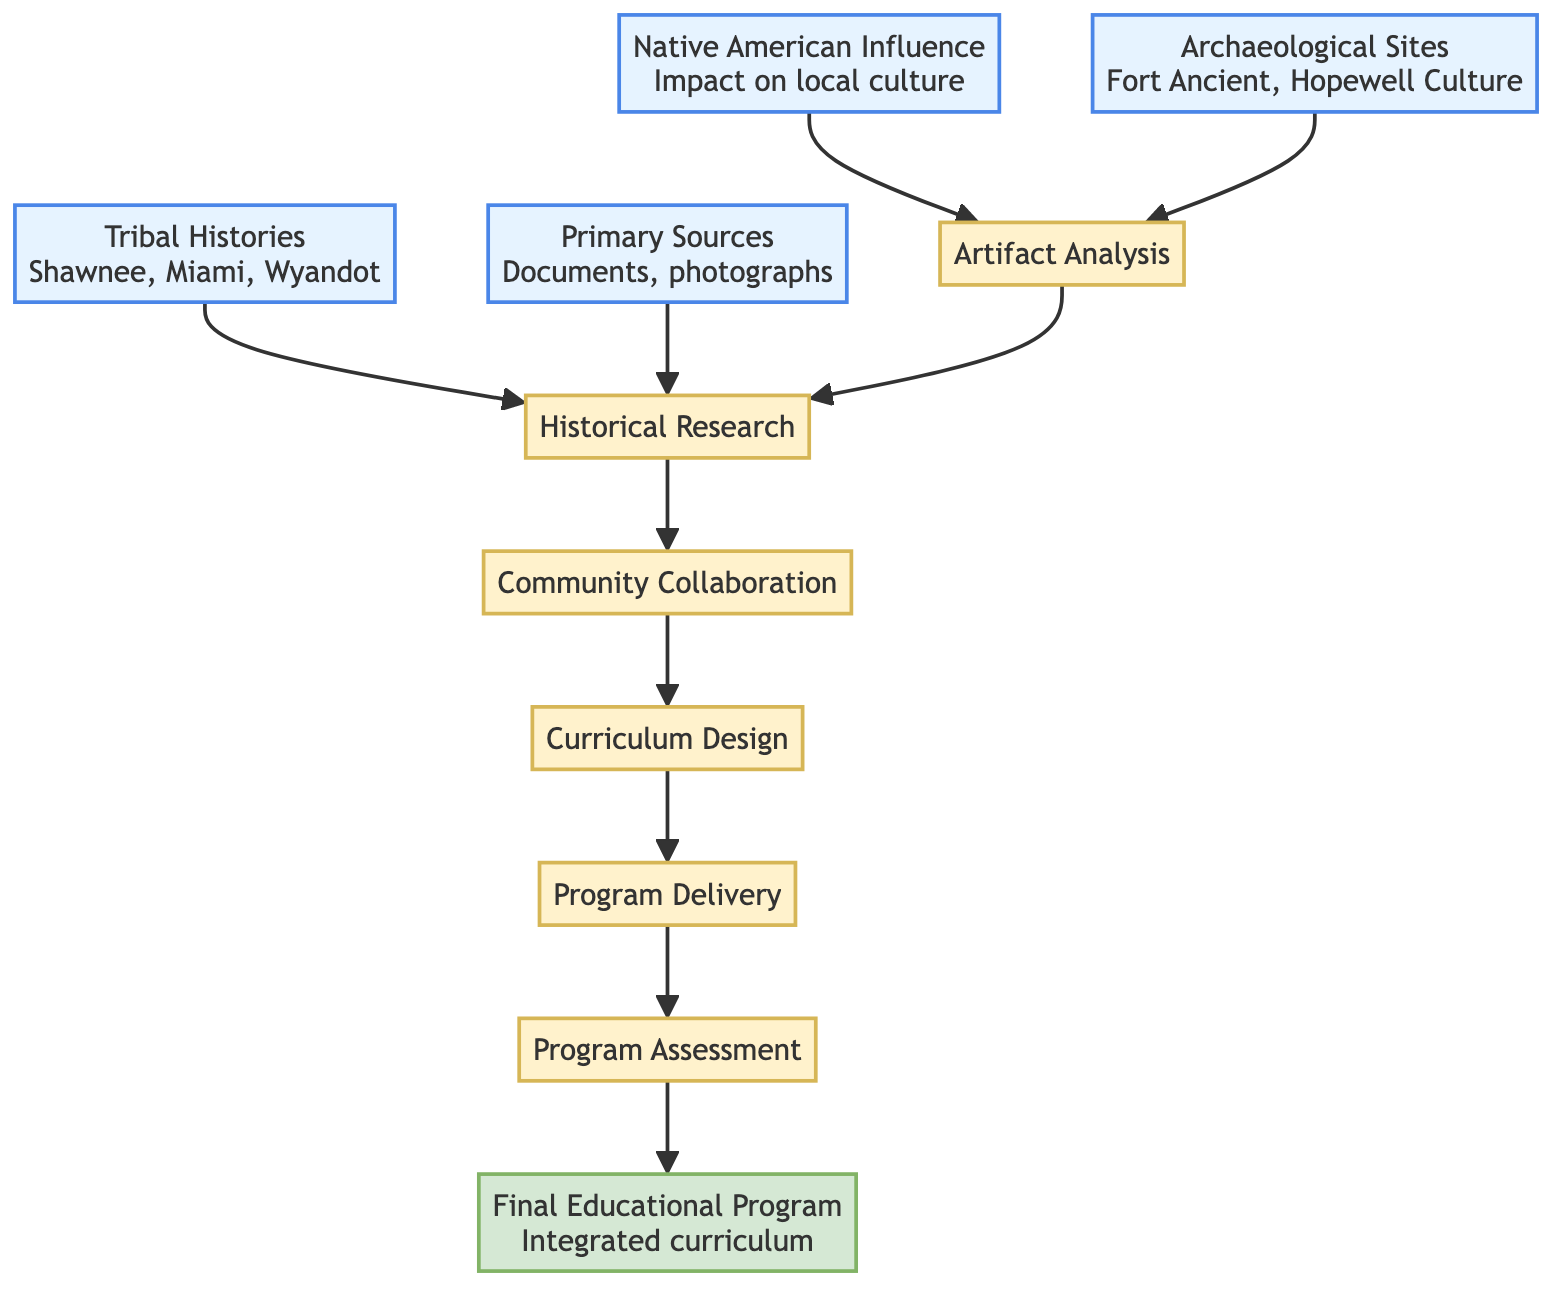What is the final output of the diagram? The final output of the diagram is found at the top of the flowchart, labeled as "Final Educational Program," which describes a completed curriculum that integrates all elements of Ohio's Native American cultural heritage.
Answer: Final Educational Program How many data nodes are present in the diagram? By examining the diagram, the data nodes include "Native American Influence," "Archaeological Sites," "Tribal Histories," and "Primary Sources." Counting these gives a total of 4 data nodes.
Answer: 4 What is the process that follows "Historical Research"? In the flowchart, "Historical Research" connects to "Community Collaboration," illustrating the next step in the process following research activities.
Answer: Community Collaboration Which data source contributes to "Artifact Analysis"? The flowchart indicates that both "Archaeological Sites" and "Native American Influence" provide information that leads to the "Artifact Analysis" process.
Answer: Native American Influence What is the purpose of "Program Assessment"? Located near the end of the flowchart, "Program Assessment" is the process involving the review and feedback from stakeholders, specifically educators, students, and Indigenous leaders.
Answer: Review and feedback How many processes are there in the diagram? To find the number of processes, we examine the nodes labeled as process: "Artifact Analysis," "Historical Research," "Community Collaboration," "Curriculum Design," "Program Delivery," and "Program Assessment." This results in a total of 6 process nodes.
Answer: 6 Which node is the immediate predecessor of "Curriculum Design"? The immediate predecessor of "Curriculum Design" in the process flow of the diagram is "Community Collaboration." It indicates that community input is required before designing the curriculum.
Answer: Community Collaboration What type of influence is being explored in the diagram? The diagram focuses on the "Native American Influence," specifically considering its impact on local culture, including aspects like art, language, and traditions within Ohio.
Answer: Native American Influence 